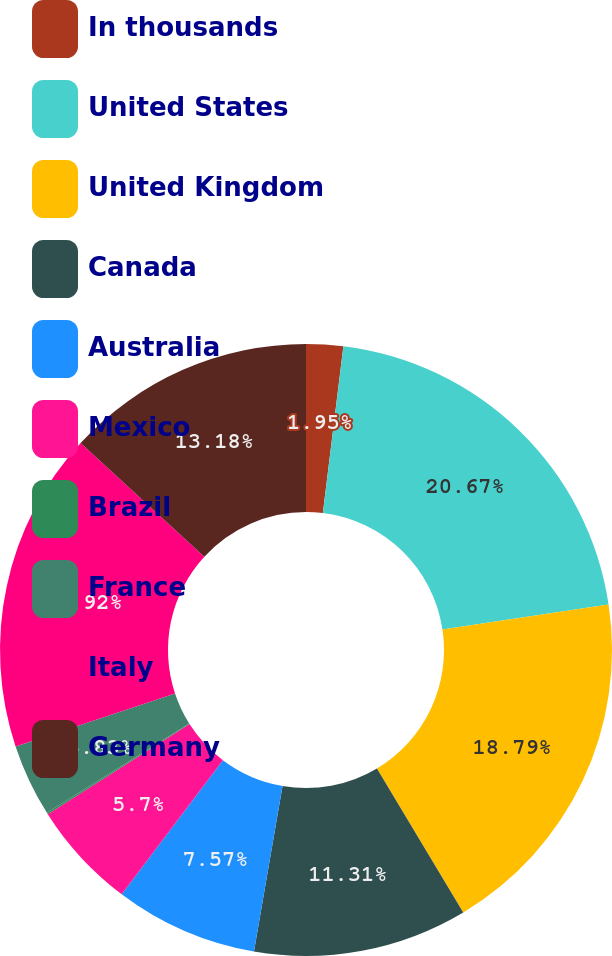Convert chart. <chart><loc_0><loc_0><loc_500><loc_500><pie_chart><fcel>In thousands<fcel>United States<fcel>United Kingdom<fcel>Canada<fcel>Australia<fcel>Mexico<fcel>Brazil<fcel>France<fcel>Italy<fcel>Germany<nl><fcel>1.95%<fcel>20.67%<fcel>18.79%<fcel>11.31%<fcel>7.57%<fcel>5.7%<fcel>0.08%<fcel>3.83%<fcel>16.92%<fcel>13.18%<nl></chart> 